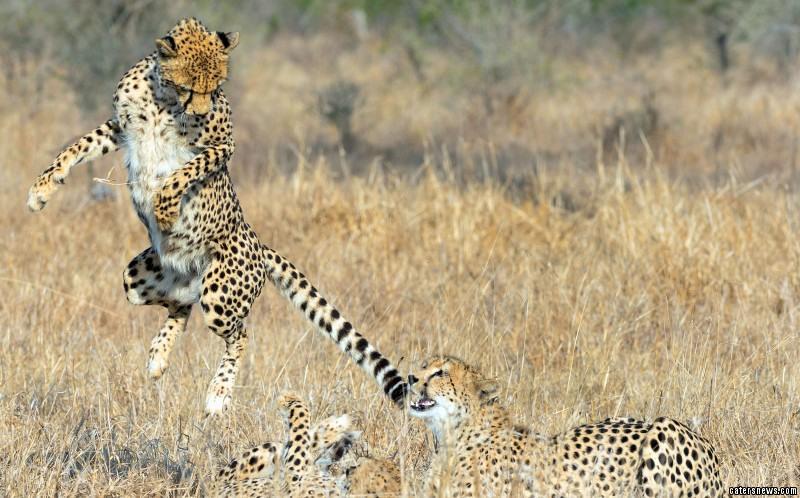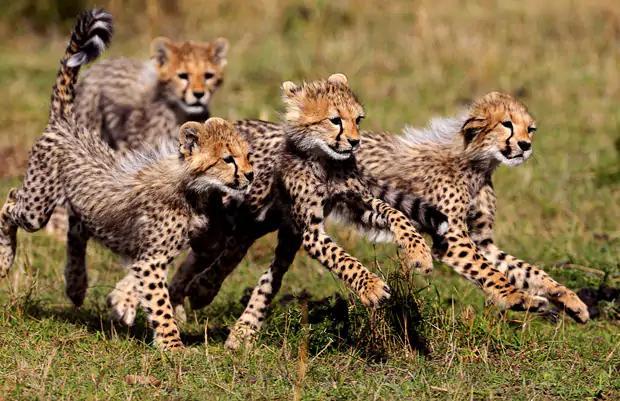The first image is the image on the left, the second image is the image on the right. Assess this claim about the two images: "There are at least four cheetahs in the right image.". Correct or not? Answer yes or no. Yes. The first image is the image on the left, the second image is the image on the right. Examine the images to the left and right. Is the description "An image includes a wild spotted cat in a pouncing pose, with its tail up and both its front paws off the ground." accurate? Answer yes or no. No. 